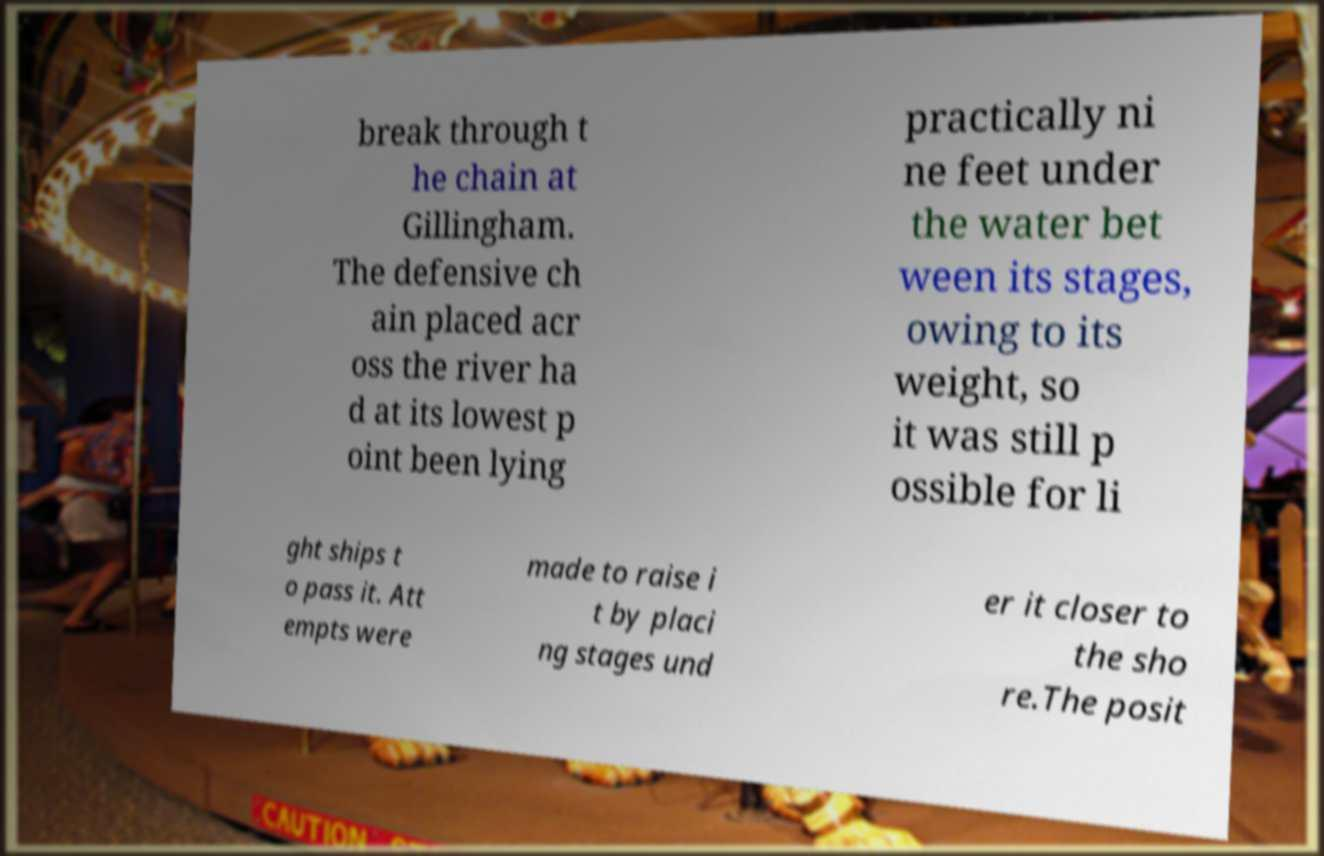Please read and relay the text visible in this image. What does it say? break through t he chain at Gillingham. The defensive ch ain placed acr oss the river ha d at its lowest p oint been lying practically ni ne feet under the water bet ween its stages, owing to its weight, so it was still p ossible for li ght ships t o pass it. Att empts were made to raise i t by placi ng stages und er it closer to the sho re.The posit 